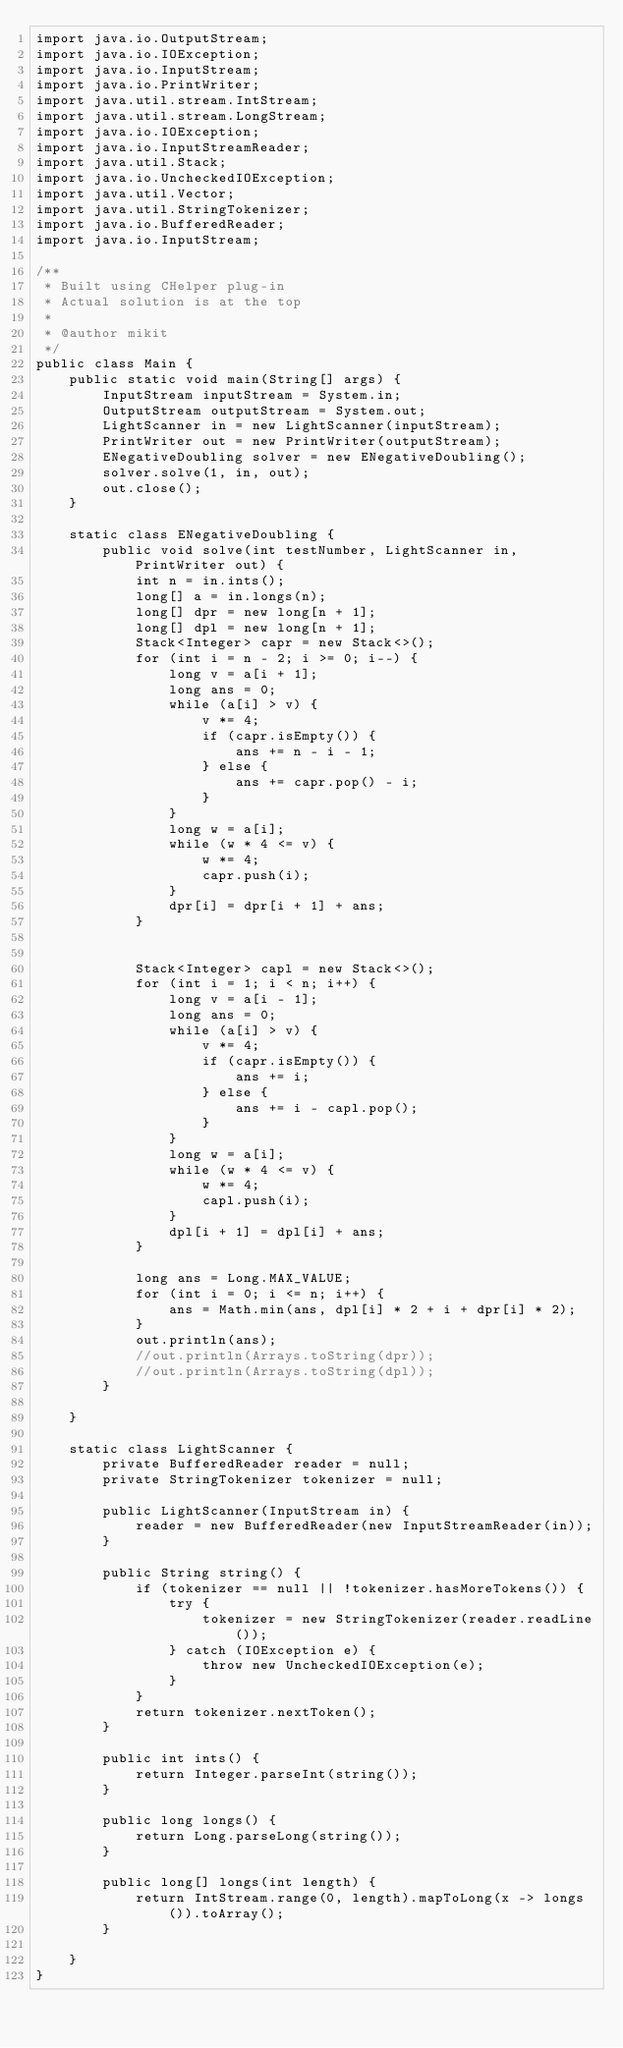Convert code to text. <code><loc_0><loc_0><loc_500><loc_500><_Java_>import java.io.OutputStream;
import java.io.IOException;
import java.io.InputStream;
import java.io.PrintWriter;
import java.util.stream.IntStream;
import java.util.stream.LongStream;
import java.io.IOException;
import java.io.InputStreamReader;
import java.util.Stack;
import java.io.UncheckedIOException;
import java.util.Vector;
import java.util.StringTokenizer;
import java.io.BufferedReader;
import java.io.InputStream;

/**
 * Built using CHelper plug-in
 * Actual solution is at the top
 *
 * @author mikit
 */
public class Main {
    public static void main(String[] args) {
        InputStream inputStream = System.in;
        OutputStream outputStream = System.out;
        LightScanner in = new LightScanner(inputStream);
        PrintWriter out = new PrintWriter(outputStream);
        ENegativeDoubling solver = new ENegativeDoubling();
        solver.solve(1, in, out);
        out.close();
    }

    static class ENegativeDoubling {
        public void solve(int testNumber, LightScanner in, PrintWriter out) {
            int n = in.ints();
            long[] a = in.longs(n);
            long[] dpr = new long[n + 1];
            long[] dpl = new long[n + 1];
            Stack<Integer> capr = new Stack<>();
            for (int i = n - 2; i >= 0; i--) {
                long v = a[i + 1];
                long ans = 0;
                while (a[i] > v) {
                    v *= 4;
                    if (capr.isEmpty()) {
                        ans += n - i - 1;
                    } else {
                        ans += capr.pop() - i;
                    }
                }
                long w = a[i];
                while (w * 4 <= v) {
                    w *= 4;
                    capr.push(i);
                }
                dpr[i] = dpr[i + 1] + ans;
            }


            Stack<Integer> capl = new Stack<>();
            for (int i = 1; i < n; i++) {
                long v = a[i - 1];
                long ans = 0;
                while (a[i] > v) {
                    v *= 4;
                    if (capr.isEmpty()) {
                        ans += i;
                    } else {
                        ans += i - capl.pop();
                    }
                }
                long w = a[i];
                while (w * 4 <= v) {
                    w *= 4;
                    capl.push(i);
                }
                dpl[i + 1] = dpl[i] + ans;
            }

            long ans = Long.MAX_VALUE;
            for (int i = 0; i <= n; i++) {
                ans = Math.min(ans, dpl[i] * 2 + i + dpr[i] * 2);
            }
            out.println(ans);
            //out.println(Arrays.toString(dpr));
            //out.println(Arrays.toString(dpl));
        }

    }

    static class LightScanner {
        private BufferedReader reader = null;
        private StringTokenizer tokenizer = null;

        public LightScanner(InputStream in) {
            reader = new BufferedReader(new InputStreamReader(in));
        }

        public String string() {
            if (tokenizer == null || !tokenizer.hasMoreTokens()) {
                try {
                    tokenizer = new StringTokenizer(reader.readLine());
                } catch (IOException e) {
                    throw new UncheckedIOException(e);
                }
            }
            return tokenizer.nextToken();
        }

        public int ints() {
            return Integer.parseInt(string());
        }

        public long longs() {
            return Long.parseLong(string());
        }

        public long[] longs(int length) {
            return IntStream.range(0, length).mapToLong(x -> longs()).toArray();
        }

    }
}

</code> 